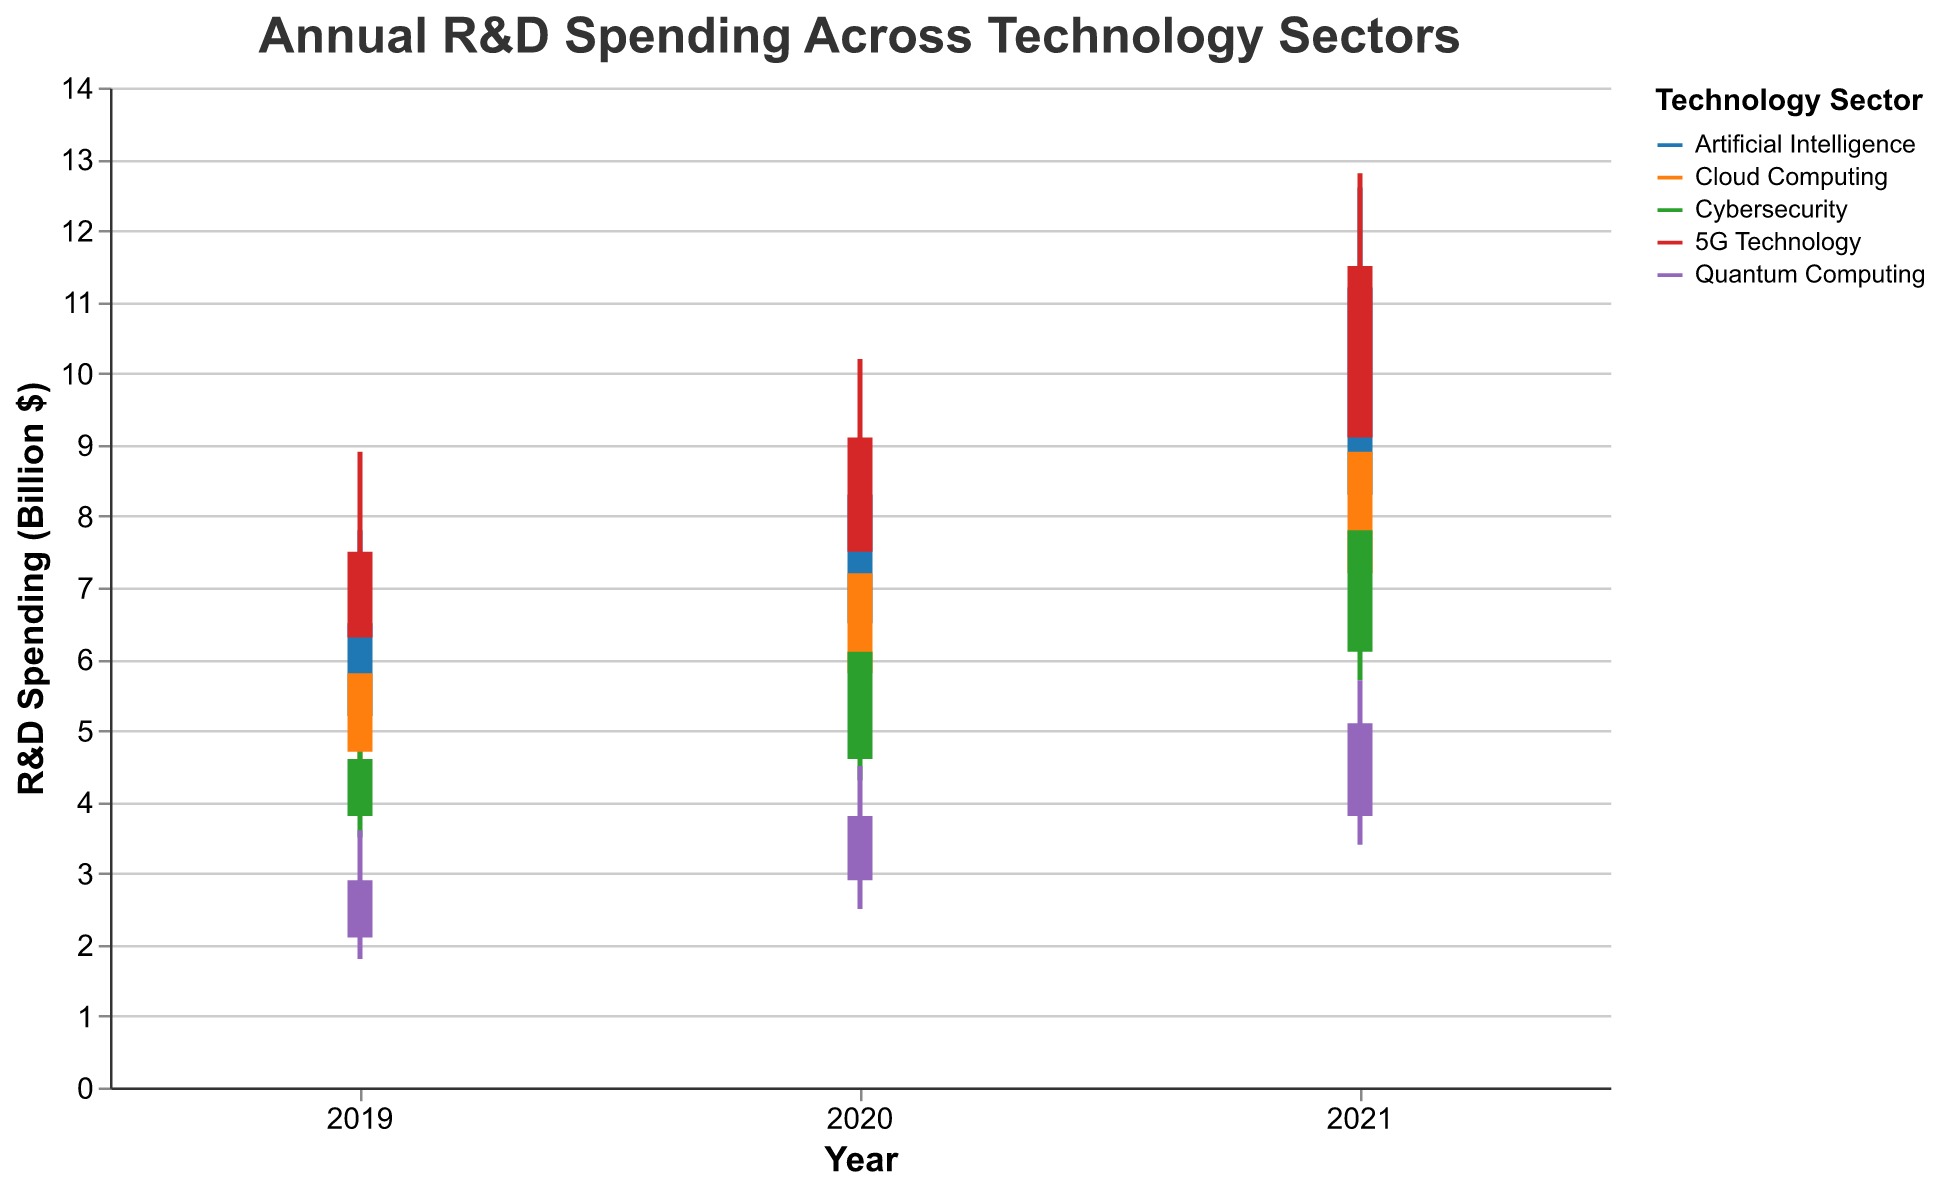What is the highest R&D spending in Artificial Intelligence over the years? Look at the "High" values for the Artificial Intelligence sector over the years. The highest value among them is 12.6 billion dollars in 2021.
Answer: 12.6 billion dollars How much did the R&D spending in 5G Technology open at in 2020? Look at the "Open" values for the 5G Technology sector in 2020, which is 7.5 billion dollars.
Answer: 7.5 billion dollars Which sector had the highest closing R&D spending in 2021? Compare the "Close" values across all sectors for 2021. The Artificial Intelligence sector had the highest closing R&D spending with 11.2 billion dollars.
Answer: Artificial Intelligence What is the average high R&D spending for Cloud Computing between 2019 and 2021? Sum the "High" values for Cloud Computing from 2019 to 2021 and divide by 3. The high values are 6.3, 7.9, and 9.5. The average is (6.3 + 7.9 + 9.5) / 3 = 23.7 / 3 = 7.9 billion dollars.
Answer: 7.9 billion dollars What was the difference between the opening and closing R&D spending in Quantum Computing in 2019? Subtract the "Open" value from the "Close" value for Quantum Computing in 2019. The values are 2.1 (open) and 2.9 (close). The difference is 2.9 - 2.1 = 0.8 billion dollars.
Answer: 0.8 billion dollars Between Artificial Intelligence and 5G Technology, which sector saw the biggest increase in their high R&D spending from 2020 to 2021? Compare the increase in "High" values from 2020 to 2021. For AI, the increase is 12.6 - 9.1 = 3.5 billion dollars. For 5G, the increase is 12.8 - 10.2 = 2.6 billion dollars. AI had the biggest increase.
Answer: Artificial Intelligence What is the range of low R&D spending for Cybersecurity from 2019 to 2021? Find the "Low" values for Cybersecurity between 2019 and 2021, which are 3.5, 4.3, and 5.7. The range is the difference between the highest and lowest values: 5.7 - 3.5 = 2.2 billion dollars.
Answer: 2.2 billion dollars Which sector had the lowest opening R&D spending in 2021? Compare the "Open" values across all sectors for 2021. Quantum Computing had the lowest opening spending with 3.8 billion dollars.
Answer: Quantum Computing How did the R&D spending for Cloud Computing change from 2019 to 2020? Look at the "Close" values for Cloud Computing in 2019 and 2020, which are 5.8 and 7.2 respectively. The spending increased by 7.2 - 5.8 = 1.4 billion dollars.
Answer: Increased by 1.4 billion dollars 